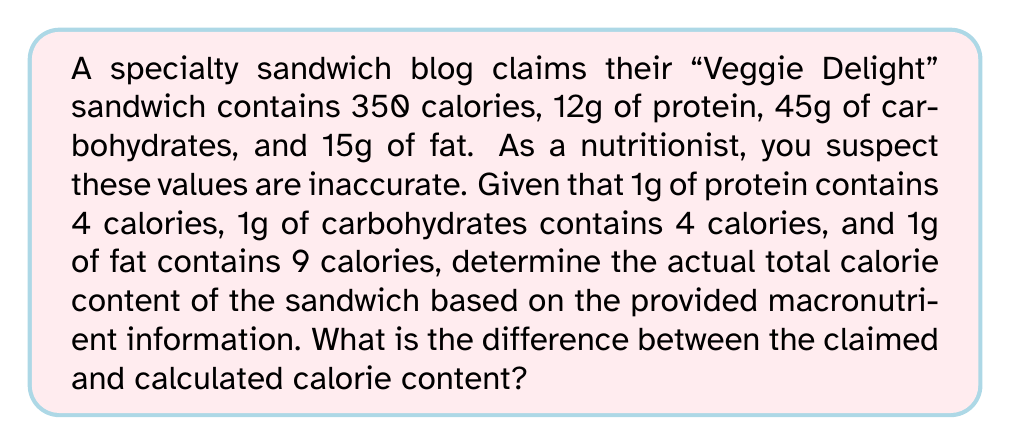Can you answer this question? To solve this inverse problem, we'll reconstruct the total calorie content from the given macronutrient information and compare it to the claimed value:

1. Calculate calories from protein:
   $12\text{g} \times 4\text{ cal/g} = 48\text{ cal}$

2. Calculate calories from carbohydrates:
   $45\text{g} \times 4\text{ cal/g} = 180\text{ cal}$

3. Calculate calories from fat:
   $15\text{g} \times 9\text{ cal/g} = 135\text{ cal}$

4. Sum up the total calories:
   $\text{Total calories} = 48 + 180 + 135 = 363\text{ cal}$

5. Calculate the difference between claimed and calculated calories:
   $\text{Difference} = 363\text{ cal} - 350\text{ cal} = 13\text{ cal}$

The calculated calorie content (363 cal) is higher than the claimed calorie content (350 cal) by 13 calories.
Answer: 13 calories 